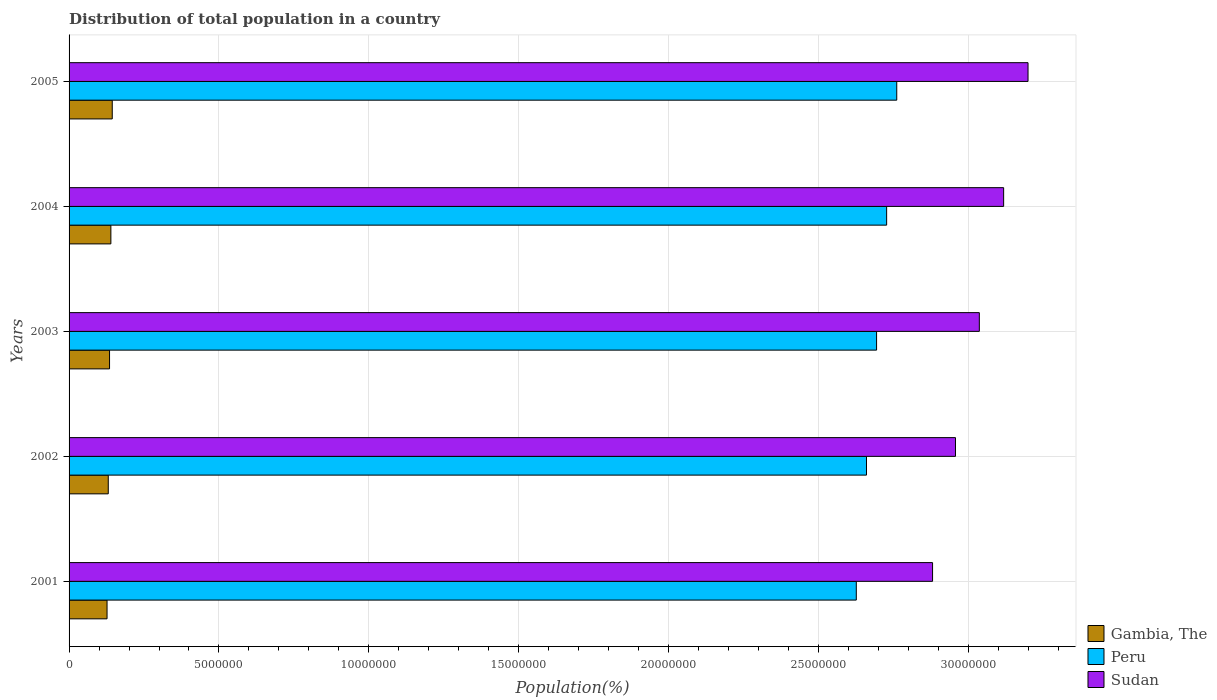Are the number of bars on each tick of the Y-axis equal?
Offer a very short reply. Yes. How many bars are there on the 5th tick from the top?
Your answer should be very brief. 3. What is the label of the 1st group of bars from the top?
Provide a short and direct response. 2005. In how many cases, is the number of bars for a given year not equal to the number of legend labels?
Give a very brief answer. 0. What is the population of in Gambia, The in 2005?
Offer a very short reply. 1.44e+06. Across all years, what is the maximum population of in Sudan?
Your answer should be compact. 3.20e+07. Across all years, what is the minimum population of in Peru?
Your response must be concise. 2.63e+07. In which year was the population of in Gambia, The maximum?
Ensure brevity in your answer.  2005. In which year was the population of in Peru minimum?
Keep it short and to the point. 2001. What is the total population of in Gambia, The in the graph?
Keep it short and to the point. 6.76e+06. What is the difference between the population of in Gambia, The in 2001 and that in 2003?
Your response must be concise. -8.32e+04. What is the difference between the population of in Peru in 2004 and the population of in Sudan in 2001?
Your answer should be compact. -1.53e+06. What is the average population of in Peru per year?
Offer a very short reply. 2.69e+07. In the year 2004, what is the difference between the population of in Gambia, The and population of in Peru?
Offer a very short reply. -2.59e+07. What is the ratio of the population of in Gambia, The in 2003 to that in 2005?
Offer a terse response. 0.94. Is the population of in Peru in 2003 less than that in 2004?
Your answer should be very brief. Yes. What is the difference between the highest and the second highest population of in Sudan?
Provide a succinct answer. 8.14e+05. What is the difference between the highest and the lowest population of in Sudan?
Provide a short and direct response. 3.18e+06. In how many years, is the population of in Peru greater than the average population of in Peru taken over all years?
Offer a very short reply. 3. What does the 2nd bar from the top in 2005 represents?
Your response must be concise. Peru. What does the 3rd bar from the bottom in 2004 represents?
Offer a very short reply. Sudan. Is it the case that in every year, the sum of the population of in Gambia, The and population of in Peru is greater than the population of in Sudan?
Offer a terse response. No. Are the values on the major ticks of X-axis written in scientific E-notation?
Provide a succinct answer. No. Does the graph contain any zero values?
Offer a very short reply. No. What is the title of the graph?
Ensure brevity in your answer.  Distribution of total population in a country. What is the label or title of the X-axis?
Your response must be concise. Population(%). What is the label or title of the Y-axis?
Offer a terse response. Years. What is the Population(%) in Gambia, The in 2001?
Make the answer very short. 1.27e+06. What is the Population(%) of Peru in 2001?
Offer a very short reply. 2.63e+07. What is the Population(%) of Sudan in 2001?
Offer a terse response. 2.88e+07. What is the Population(%) in Gambia, The in 2002?
Your answer should be compact. 1.31e+06. What is the Population(%) of Peru in 2002?
Your answer should be very brief. 2.66e+07. What is the Population(%) of Sudan in 2002?
Give a very brief answer. 2.96e+07. What is the Population(%) of Gambia, The in 2003?
Your answer should be very brief. 1.35e+06. What is the Population(%) of Peru in 2003?
Keep it short and to the point. 2.69e+07. What is the Population(%) in Sudan in 2003?
Offer a very short reply. 3.04e+07. What is the Population(%) of Gambia, The in 2004?
Offer a terse response. 1.39e+06. What is the Population(%) in Peru in 2004?
Give a very brief answer. 2.73e+07. What is the Population(%) of Sudan in 2004?
Ensure brevity in your answer.  3.12e+07. What is the Population(%) of Gambia, The in 2005?
Your answer should be compact. 1.44e+06. What is the Population(%) in Peru in 2005?
Make the answer very short. 2.76e+07. What is the Population(%) of Sudan in 2005?
Keep it short and to the point. 3.20e+07. Across all years, what is the maximum Population(%) in Gambia, The?
Your answer should be compact. 1.44e+06. Across all years, what is the maximum Population(%) of Peru?
Ensure brevity in your answer.  2.76e+07. Across all years, what is the maximum Population(%) in Sudan?
Make the answer very short. 3.20e+07. Across all years, what is the minimum Population(%) in Gambia, The?
Offer a terse response. 1.27e+06. Across all years, what is the minimum Population(%) in Peru?
Your answer should be compact. 2.63e+07. Across all years, what is the minimum Population(%) of Sudan?
Offer a very short reply. 2.88e+07. What is the total Population(%) of Gambia, The in the graph?
Ensure brevity in your answer.  6.76e+06. What is the total Population(%) in Peru in the graph?
Provide a short and direct response. 1.35e+08. What is the total Population(%) of Sudan in the graph?
Provide a succinct answer. 1.52e+08. What is the difference between the Population(%) of Gambia, The in 2001 and that in 2002?
Offer a terse response. -4.06e+04. What is the difference between the Population(%) of Peru in 2001 and that in 2002?
Your response must be concise. -3.40e+05. What is the difference between the Population(%) of Sudan in 2001 and that in 2002?
Give a very brief answer. -7.65e+05. What is the difference between the Population(%) of Gambia, The in 2001 and that in 2003?
Provide a succinct answer. -8.32e+04. What is the difference between the Population(%) of Peru in 2001 and that in 2003?
Provide a short and direct response. -6.76e+05. What is the difference between the Population(%) in Sudan in 2001 and that in 2003?
Keep it short and to the point. -1.56e+06. What is the difference between the Population(%) of Gambia, The in 2001 and that in 2004?
Offer a very short reply. -1.28e+05. What is the difference between the Population(%) in Peru in 2001 and that in 2004?
Offer a terse response. -1.01e+06. What is the difference between the Population(%) in Sudan in 2001 and that in 2004?
Make the answer very short. -2.37e+06. What is the difference between the Population(%) of Gambia, The in 2001 and that in 2005?
Provide a succinct answer. -1.73e+05. What is the difference between the Population(%) of Peru in 2001 and that in 2005?
Offer a very short reply. -1.35e+06. What is the difference between the Population(%) in Sudan in 2001 and that in 2005?
Offer a very short reply. -3.18e+06. What is the difference between the Population(%) of Gambia, The in 2002 and that in 2003?
Provide a succinct answer. -4.27e+04. What is the difference between the Population(%) of Peru in 2002 and that in 2003?
Make the answer very short. -3.36e+05. What is the difference between the Population(%) in Sudan in 2002 and that in 2003?
Offer a terse response. -7.96e+05. What is the difference between the Population(%) of Gambia, The in 2002 and that in 2004?
Your answer should be compact. -8.71e+04. What is the difference between the Population(%) in Peru in 2002 and that in 2004?
Provide a succinct answer. -6.72e+05. What is the difference between the Population(%) in Sudan in 2002 and that in 2004?
Your response must be concise. -1.61e+06. What is the difference between the Population(%) of Gambia, The in 2002 and that in 2005?
Make the answer very short. -1.33e+05. What is the difference between the Population(%) of Peru in 2002 and that in 2005?
Ensure brevity in your answer.  -1.01e+06. What is the difference between the Population(%) of Sudan in 2002 and that in 2005?
Keep it short and to the point. -2.42e+06. What is the difference between the Population(%) of Gambia, The in 2003 and that in 2004?
Give a very brief answer. -4.44e+04. What is the difference between the Population(%) in Peru in 2003 and that in 2004?
Your answer should be compact. -3.35e+05. What is the difference between the Population(%) in Sudan in 2003 and that in 2004?
Your answer should be very brief. -8.11e+05. What is the difference between the Population(%) in Gambia, The in 2003 and that in 2005?
Your answer should be very brief. -9.02e+04. What is the difference between the Population(%) of Peru in 2003 and that in 2005?
Offer a terse response. -6.73e+05. What is the difference between the Population(%) of Sudan in 2003 and that in 2005?
Your answer should be very brief. -1.62e+06. What is the difference between the Population(%) of Gambia, The in 2004 and that in 2005?
Give a very brief answer. -4.58e+04. What is the difference between the Population(%) of Peru in 2004 and that in 2005?
Your answer should be compact. -3.37e+05. What is the difference between the Population(%) in Sudan in 2004 and that in 2005?
Make the answer very short. -8.14e+05. What is the difference between the Population(%) of Gambia, The in 2001 and the Population(%) of Peru in 2002?
Offer a terse response. -2.53e+07. What is the difference between the Population(%) of Gambia, The in 2001 and the Population(%) of Sudan in 2002?
Provide a short and direct response. -2.83e+07. What is the difference between the Population(%) of Peru in 2001 and the Population(%) of Sudan in 2002?
Keep it short and to the point. -3.31e+06. What is the difference between the Population(%) of Gambia, The in 2001 and the Population(%) of Peru in 2003?
Provide a succinct answer. -2.57e+07. What is the difference between the Population(%) of Gambia, The in 2001 and the Population(%) of Sudan in 2003?
Your response must be concise. -2.91e+07. What is the difference between the Population(%) of Peru in 2001 and the Population(%) of Sudan in 2003?
Offer a very short reply. -4.10e+06. What is the difference between the Population(%) in Gambia, The in 2001 and the Population(%) in Peru in 2004?
Your answer should be compact. -2.60e+07. What is the difference between the Population(%) of Gambia, The in 2001 and the Population(%) of Sudan in 2004?
Make the answer very short. -2.99e+07. What is the difference between the Population(%) of Peru in 2001 and the Population(%) of Sudan in 2004?
Your response must be concise. -4.91e+06. What is the difference between the Population(%) in Gambia, The in 2001 and the Population(%) in Peru in 2005?
Give a very brief answer. -2.63e+07. What is the difference between the Population(%) of Gambia, The in 2001 and the Population(%) of Sudan in 2005?
Ensure brevity in your answer.  -3.07e+07. What is the difference between the Population(%) of Peru in 2001 and the Population(%) of Sudan in 2005?
Offer a very short reply. -5.73e+06. What is the difference between the Population(%) of Gambia, The in 2002 and the Population(%) of Peru in 2003?
Ensure brevity in your answer.  -2.56e+07. What is the difference between the Population(%) of Gambia, The in 2002 and the Population(%) of Sudan in 2003?
Offer a very short reply. -2.91e+07. What is the difference between the Population(%) in Peru in 2002 and the Population(%) in Sudan in 2003?
Your answer should be very brief. -3.76e+06. What is the difference between the Population(%) in Gambia, The in 2002 and the Population(%) in Peru in 2004?
Make the answer very short. -2.60e+07. What is the difference between the Population(%) in Gambia, The in 2002 and the Population(%) in Sudan in 2004?
Give a very brief answer. -2.99e+07. What is the difference between the Population(%) of Peru in 2002 and the Population(%) of Sudan in 2004?
Offer a very short reply. -4.57e+06. What is the difference between the Population(%) of Gambia, The in 2002 and the Population(%) of Peru in 2005?
Give a very brief answer. -2.63e+07. What is the difference between the Population(%) of Gambia, The in 2002 and the Population(%) of Sudan in 2005?
Your answer should be compact. -3.07e+07. What is the difference between the Population(%) of Peru in 2002 and the Population(%) of Sudan in 2005?
Keep it short and to the point. -5.39e+06. What is the difference between the Population(%) of Gambia, The in 2003 and the Population(%) of Peru in 2004?
Your answer should be compact. -2.59e+07. What is the difference between the Population(%) of Gambia, The in 2003 and the Population(%) of Sudan in 2004?
Ensure brevity in your answer.  -2.98e+07. What is the difference between the Population(%) of Peru in 2003 and the Population(%) of Sudan in 2004?
Your answer should be compact. -4.24e+06. What is the difference between the Population(%) of Gambia, The in 2003 and the Population(%) of Peru in 2005?
Offer a very short reply. -2.63e+07. What is the difference between the Population(%) of Gambia, The in 2003 and the Population(%) of Sudan in 2005?
Provide a short and direct response. -3.06e+07. What is the difference between the Population(%) in Peru in 2003 and the Population(%) in Sudan in 2005?
Provide a succinct answer. -5.05e+06. What is the difference between the Population(%) of Gambia, The in 2004 and the Population(%) of Peru in 2005?
Offer a terse response. -2.62e+07. What is the difference between the Population(%) in Gambia, The in 2004 and the Population(%) in Sudan in 2005?
Your answer should be very brief. -3.06e+07. What is the difference between the Population(%) of Peru in 2004 and the Population(%) of Sudan in 2005?
Your answer should be compact. -4.72e+06. What is the average Population(%) of Gambia, The per year?
Offer a terse response. 1.35e+06. What is the average Population(%) in Peru per year?
Make the answer very short. 2.69e+07. What is the average Population(%) in Sudan per year?
Provide a succinct answer. 3.04e+07. In the year 2001, what is the difference between the Population(%) of Gambia, The and Population(%) of Peru?
Your answer should be very brief. -2.50e+07. In the year 2001, what is the difference between the Population(%) of Gambia, The and Population(%) of Sudan?
Keep it short and to the point. -2.75e+07. In the year 2001, what is the difference between the Population(%) in Peru and Population(%) in Sudan?
Your response must be concise. -2.54e+06. In the year 2002, what is the difference between the Population(%) in Gambia, The and Population(%) in Peru?
Ensure brevity in your answer.  -2.53e+07. In the year 2002, what is the difference between the Population(%) of Gambia, The and Population(%) of Sudan?
Provide a short and direct response. -2.83e+07. In the year 2002, what is the difference between the Population(%) of Peru and Population(%) of Sudan?
Keep it short and to the point. -2.97e+06. In the year 2003, what is the difference between the Population(%) in Gambia, The and Population(%) in Peru?
Offer a terse response. -2.56e+07. In the year 2003, what is the difference between the Population(%) of Gambia, The and Population(%) of Sudan?
Make the answer very short. -2.90e+07. In the year 2003, what is the difference between the Population(%) in Peru and Population(%) in Sudan?
Your answer should be compact. -3.43e+06. In the year 2004, what is the difference between the Population(%) in Gambia, The and Population(%) in Peru?
Provide a succinct answer. -2.59e+07. In the year 2004, what is the difference between the Population(%) of Gambia, The and Population(%) of Sudan?
Ensure brevity in your answer.  -2.98e+07. In the year 2004, what is the difference between the Population(%) of Peru and Population(%) of Sudan?
Provide a succinct answer. -3.90e+06. In the year 2005, what is the difference between the Population(%) of Gambia, The and Population(%) of Peru?
Your response must be concise. -2.62e+07. In the year 2005, what is the difference between the Population(%) of Gambia, The and Population(%) of Sudan?
Make the answer very short. -3.05e+07. In the year 2005, what is the difference between the Population(%) in Peru and Population(%) in Sudan?
Provide a succinct answer. -4.38e+06. What is the ratio of the Population(%) in Gambia, The in 2001 to that in 2002?
Offer a terse response. 0.97. What is the ratio of the Population(%) of Peru in 2001 to that in 2002?
Keep it short and to the point. 0.99. What is the ratio of the Population(%) of Sudan in 2001 to that in 2002?
Make the answer very short. 0.97. What is the ratio of the Population(%) in Gambia, The in 2001 to that in 2003?
Make the answer very short. 0.94. What is the ratio of the Population(%) of Peru in 2001 to that in 2003?
Your answer should be compact. 0.97. What is the ratio of the Population(%) of Sudan in 2001 to that in 2003?
Offer a terse response. 0.95. What is the ratio of the Population(%) of Gambia, The in 2001 to that in 2004?
Make the answer very short. 0.91. What is the ratio of the Population(%) in Peru in 2001 to that in 2004?
Offer a very short reply. 0.96. What is the ratio of the Population(%) of Sudan in 2001 to that in 2004?
Give a very brief answer. 0.92. What is the ratio of the Population(%) in Gambia, The in 2001 to that in 2005?
Make the answer very short. 0.88. What is the ratio of the Population(%) in Peru in 2001 to that in 2005?
Keep it short and to the point. 0.95. What is the ratio of the Population(%) in Sudan in 2001 to that in 2005?
Provide a short and direct response. 0.9. What is the ratio of the Population(%) in Gambia, The in 2002 to that in 2003?
Your response must be concise. 0.97. What is the ratio of the Population(%) of Peru in 2002 to that in 2003?
Ensure brevity in your answer.  0.99. What is the ratio of the Population(%) of Sudan in 2002 to that in 2003?
Your response must be concise. 0.97. What is the ratio of the Population(%) in Gambia, The in 2002 to that in 2004?
Offer a terse response. 0.94. What is the ratio of the Population(%) of Peru in 2002 to that in 2004?
Provide a short and direct response. 0.98. What is the ratio of the Population(%) of Sudan in 2002 to that in 2004?
Offer a terse response. 0.95. What is the ratio of the Population(%) in Gambia, The in 2002 to that in 2005?
Offer a very short reply. 0.91. What is the ratio of the Population(%) of Peru in 2002 to that in 2005?
Your response must be concise. 0.96. What is the ratio of the Population(%) of Sudan in 2002 to that in 2005?
Give a very brief answer. 0.92. What is the ratio of the Population(%) in Gambia, The in 2003 to that in 2004?
Provide a short and direct response. 0.97. What is the ratio of the Population(%) in Peru in 2003 to that in 2004?
Your answer should be very brief. 0.99. What is the ratio of the Population(%) of Gambia, The in 2003 to that in 2005?
Your answer should be compact. 0.94. What is the ratio of the Population(%) of Peru in 2003 to that in 2005?
Make the answer very short. 0.98. What is the ratio of the Population(%) in Sudan in 2003 to that in 2005?
Provide a succinct answer. 0.95. What is the ratio of the Population(%) in Gambia, The in 2004 to that in 2005?
Give a very brief answer. 0.97. What is the ratio of the Population(%) of Sudan in 2004 to that in 2005?
Your answer should be compact. 0.97. What is the difference between the highest and the second highest Population(%) of Gambia, The?
Your response must be concise. 4.58e+04. What is the difference between the highest and the second highest Population(%) in Peru?
Make the answer very short. 3.37e+05. What is the difference between the highest and the second highest Population(%) in Sudan?
Provide a succinct answer. 8.14e+05. What is the difference between the highest and the lowest Population(%) in Gambia, The?
Provide a short and direct response. 1.73e+05. What is the difference between the highest and the lowest Population(%) in Peru?
Your answer should be compact. 1.35e+06. What is the difference between the highest and the lowest Population(%) in Sudan?
Keep it short and to the point. 3.18e+06. 